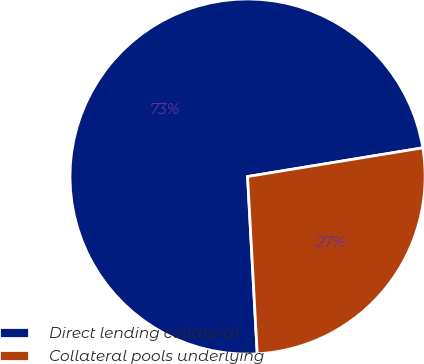<chart> <loc_0><loc_0><loc_500><loc_500><pie_chart><fcel>Direct lending collateral<fcel>Collateral pools underlying<nl><fcel>73.28%<fcel>26.72%<nl></chart> 